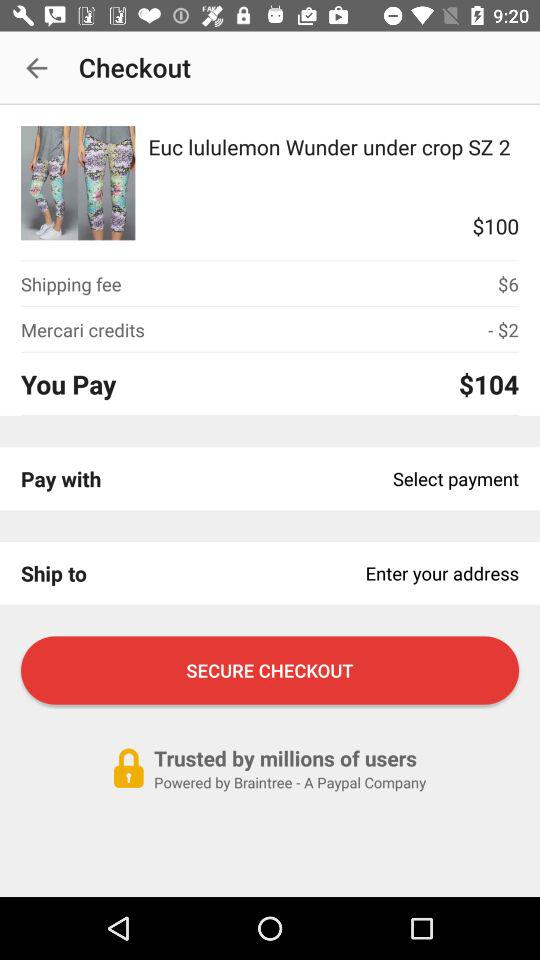How much will you have to pay? You will have to pay $104. 